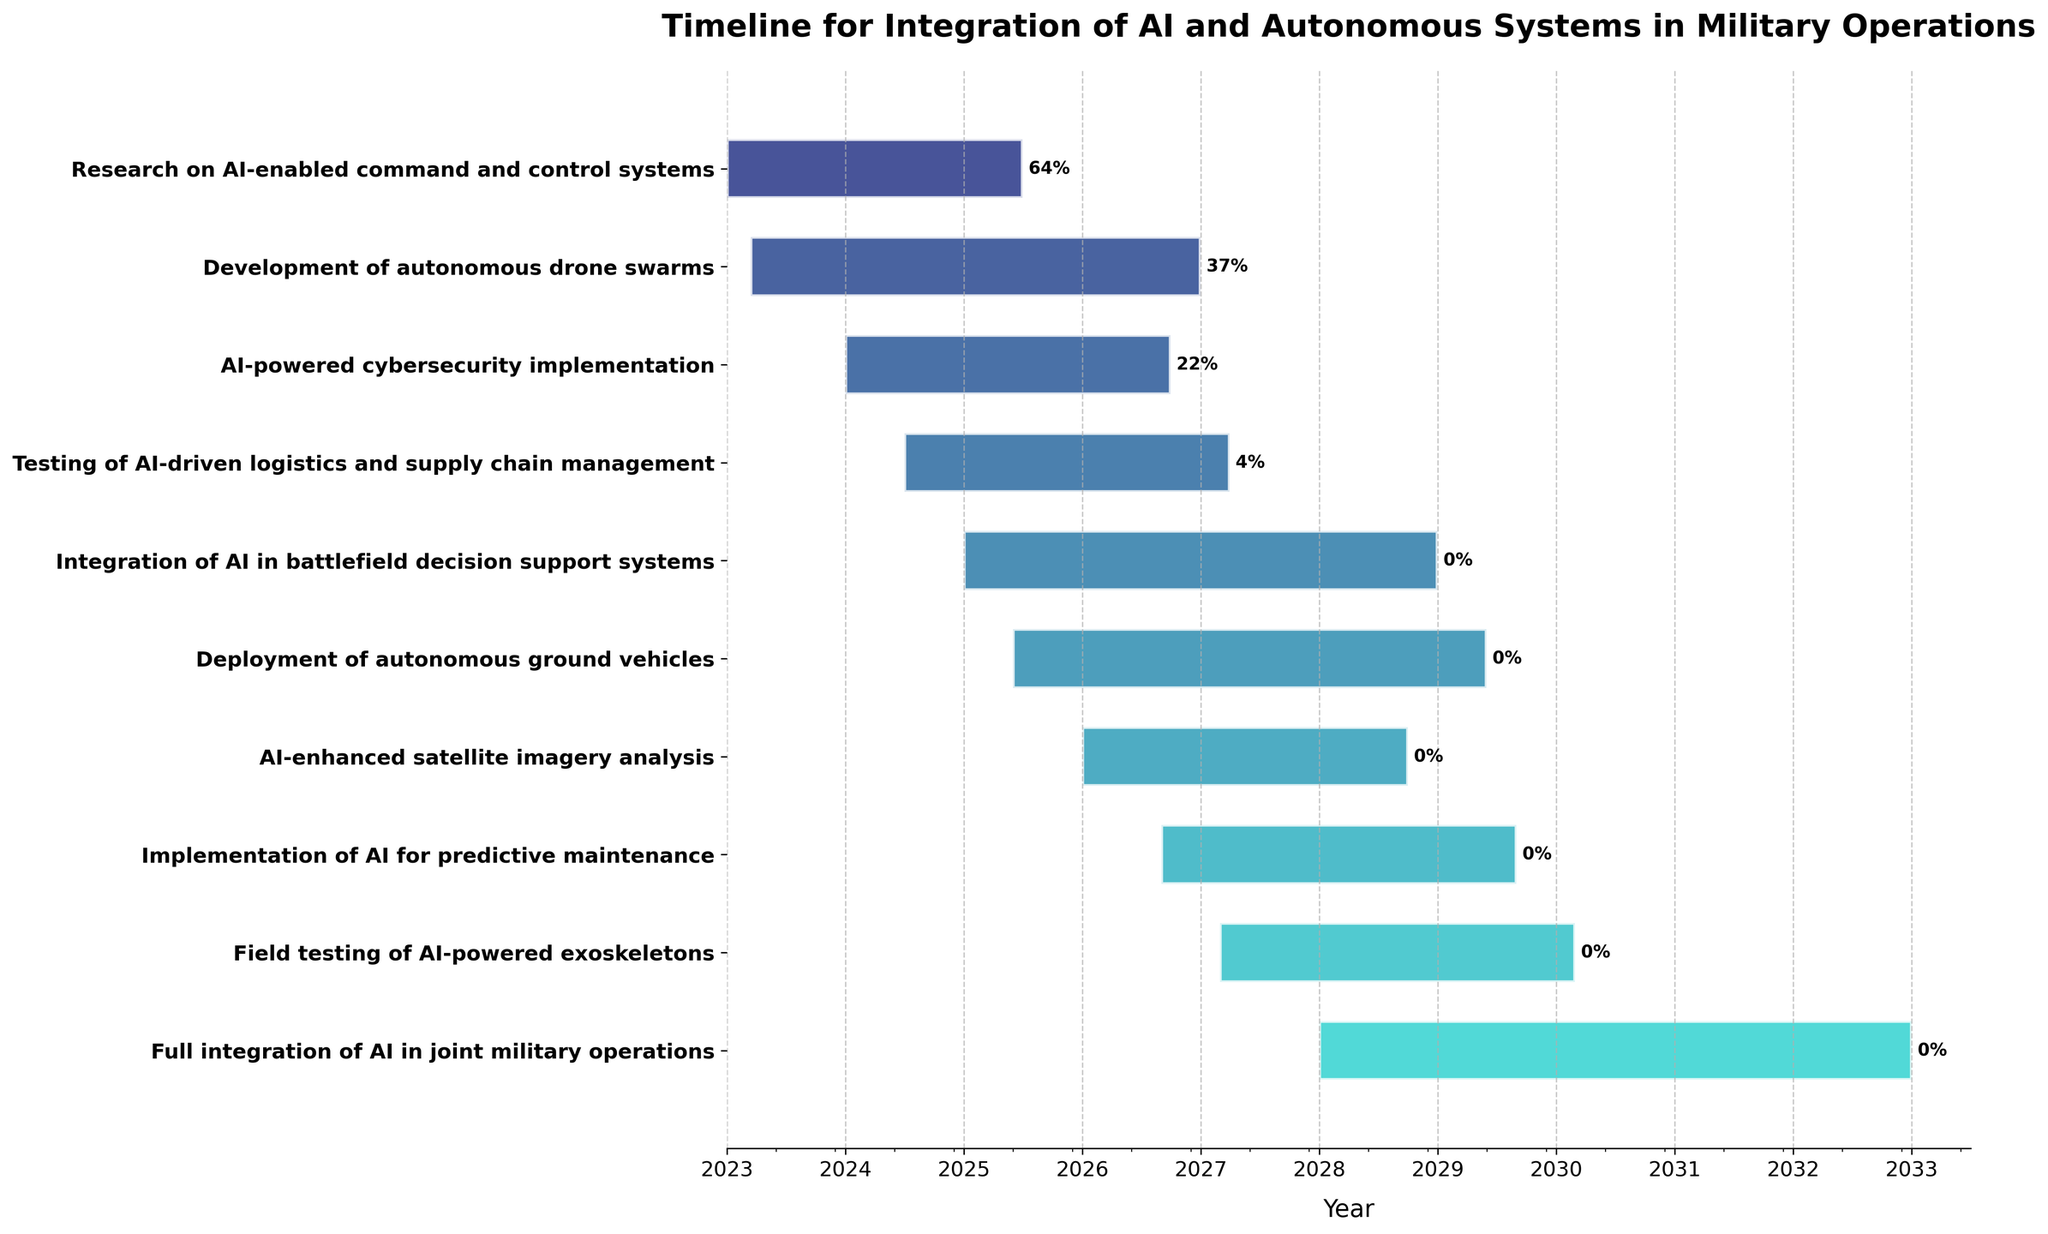What is the title of the chart? The title is typically located at the top of the chart and usually indicates the overall subject matter of the visualization.
Answer: Timeline for Integration of AI and Autonomous Systems in Military Operations Which task has the earliest start date? To find this, look at the task bars and identify the one that starts at the furthest left on the time axis.
Answer: Research on AI-enabled command and control systems How many tasks are shown in the chart? Count the number of horizontal bars, each of which represents a task.
Answer: 10 Which task will be completed last according to the timeline? Observe which task bar extends the furthest to the right on the time axis.
Answer: Full integration of AI in joint military operations What is the time span for the development of autonomous drone swarms? Subtract the start date from the end date of the "Development of autonomous drone swarms" task to find the duration.
Answer: 2023-03-15 to 2026-12-31, which spans approximately 3 years and 9 months Which tasks have overlapping timelines starting from 2025? Identify the tasks with time bars that intersect the year 2025 on the time axis.
Answer: Multiple tasks including Integration of AI in battlefield decision support systems and Deployment of autonomous ground vehicles What is the duration of the shortest task in the timeline? Compare the length of all task bars and identify the shortest one. Calculate the duration in days if necessary.
Answer: Research on AI-enabled command and control systems from 2023-01-01 to 2025-06-30, which spans approximately 2 years and 6 months How many tasks start after 2026? Count the number of task bars that begin after the year 2026.
Answer: 3 tasks Which task has the highest completion percentage as of now? Identify the task that completes earlier relative to the current date and check the percentage labels.
Answer: Research on AI-enabled command and control systems (assuming the current date is before its end date) What is the timeline overlap between AI-powered cybersecurity implementation and Testing of AI-driven logistics and supply chain management? Compare their timelines and calculate the overlapping period where both tasks are active.
Answer: Both tasks overlap between 2024-07-01 and 2026-09-30, which is approximately 2 years and 2 months 